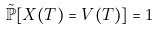Convert formula to latex. <formula><loc_0><loc_0><loc_500><loc_500>\tilde { \mathbb { P } } [ X ( T ) = V ( T ) ] = 1</formula> 